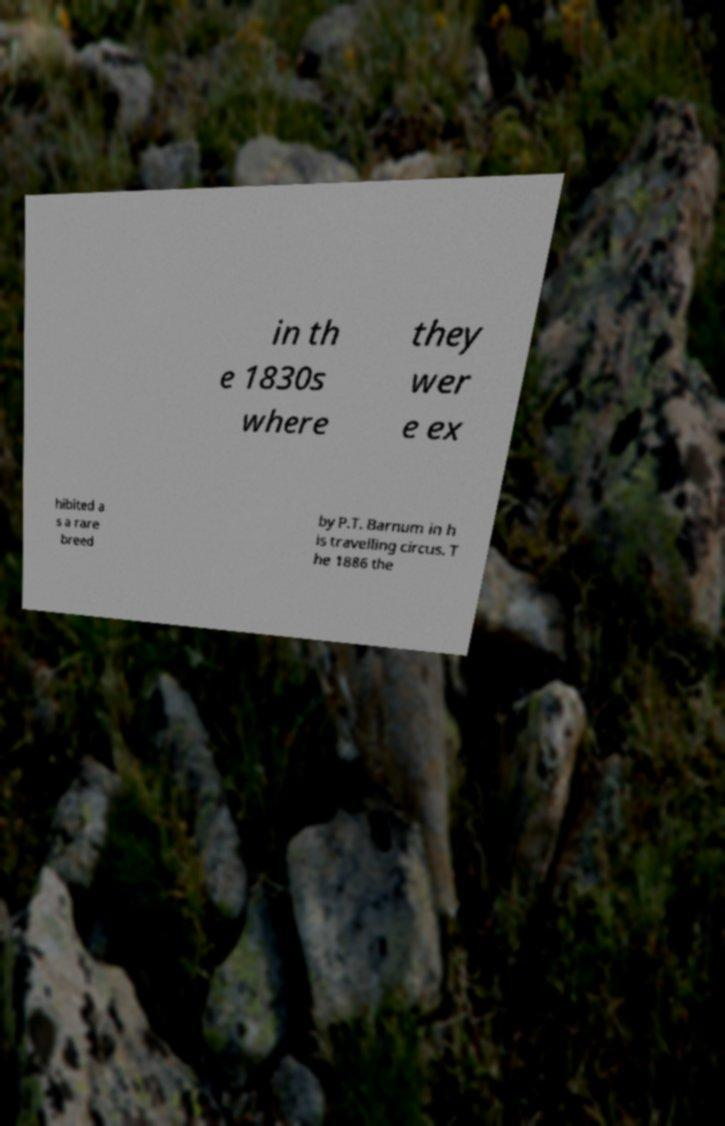Please identify and transcribe the text found in this image. in th e 1830s where they wer e ex hibited a s a rare breed by P.T. Barnum in h is travelling circus. T he 1886 the 